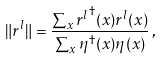<formula> <loc_0><loc_0><loc_500><loc_500>\| r ^ { l } \| = \frac { \sum _ { x } { r ^ { l } } ^ { \dagger } ( x ) r ^ { l } ( x ) } { \sum _ { x } \eta ^ { \dagger } ( x ) \eta ( x ) } \, ,</formula> 